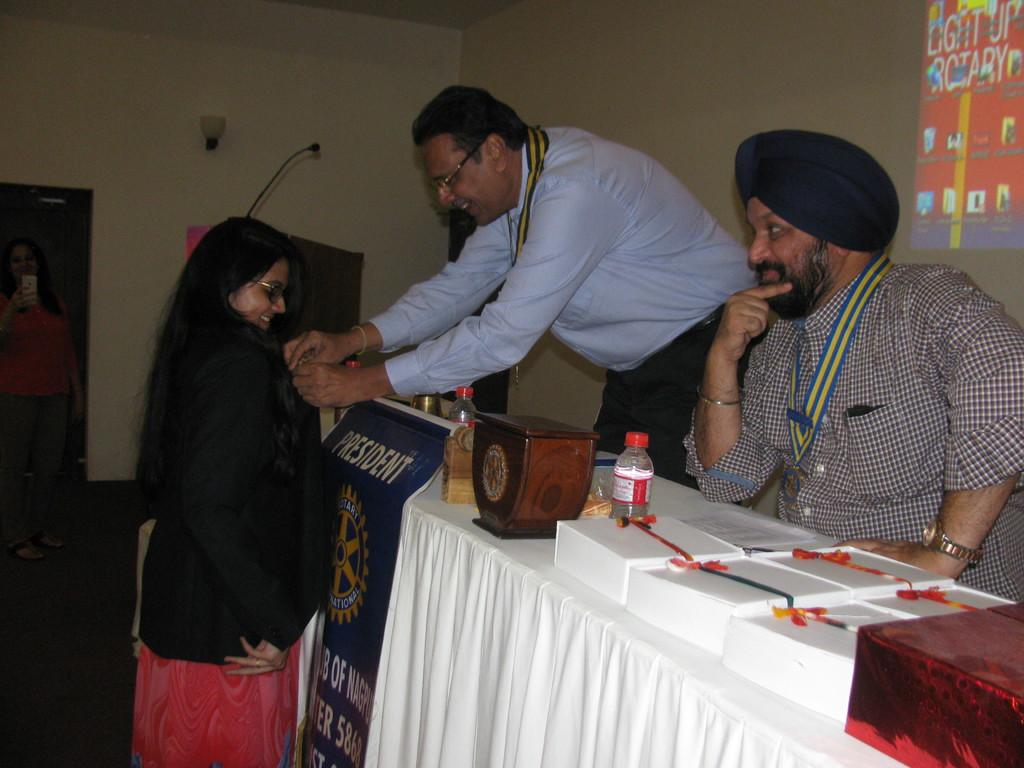What is the man's title?
Make the answer very short. President. What type of rotary is mention on the wall?
Give a very brief answer. Light up. 